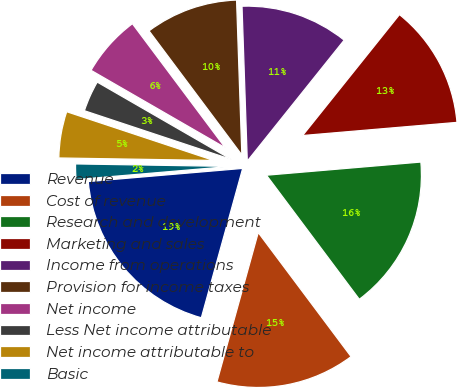<chart> <loc_0><loc_0><loc_500><loc_500><pie_chart><fcel>Revenue<fcel>Cost of revenue<fcel>Research and development<fcel>Marketing and sales<fcel>Income from operations<fcel>Provision for income taxes<fcel>Net income<fcel>Less Net income attributable<fcel>Net income attributable to<fcel>Basic<nl><fcel>19.35%<fcel>14.52%<fcel>16.13%<fcel>12.9%<fcel>11.29%<fcel>9.68%<fcel>6.45%<fcel>3.23%<fcel>4.84%<fcel>1.61%<nl></chart> 